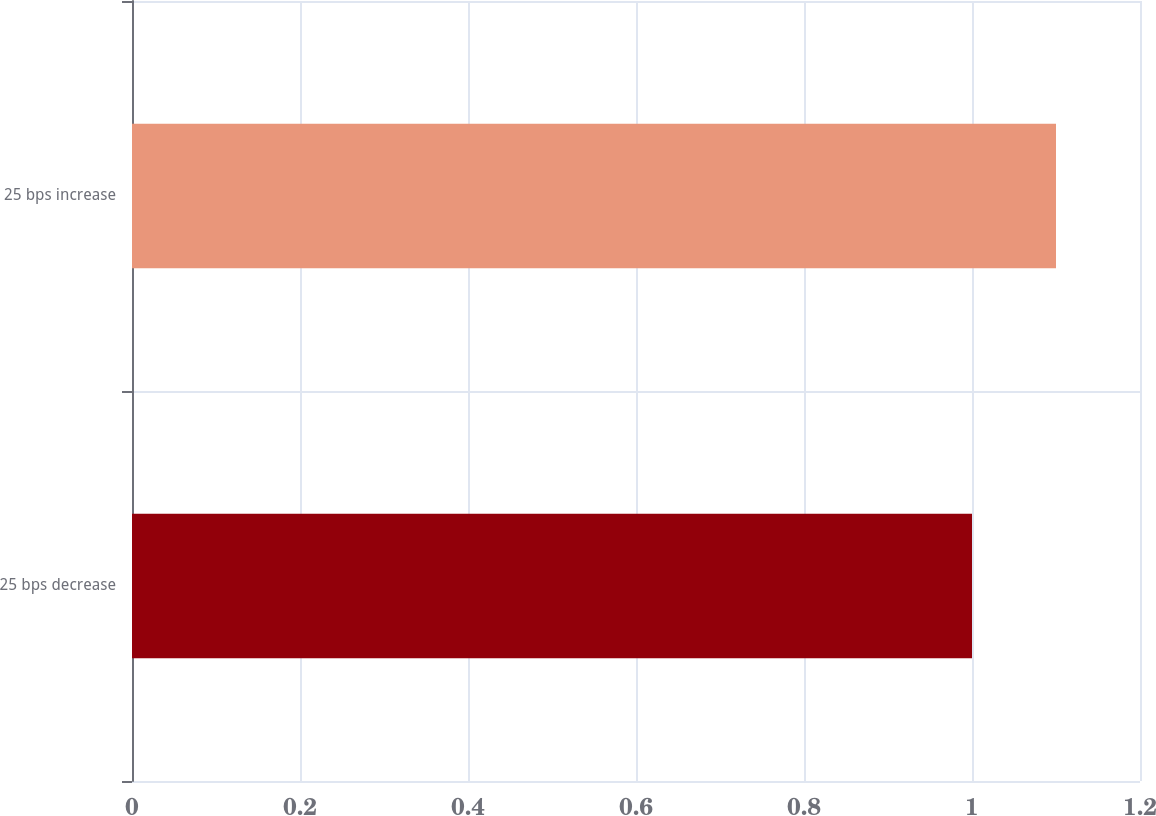<chart> <loc_0><loc_0><loc_500><loc_500><bar_chart><fcel>25 bps decrease<fcel>25 bps increase<nl><fcel>1<fcel>1.1<nl></chart> 